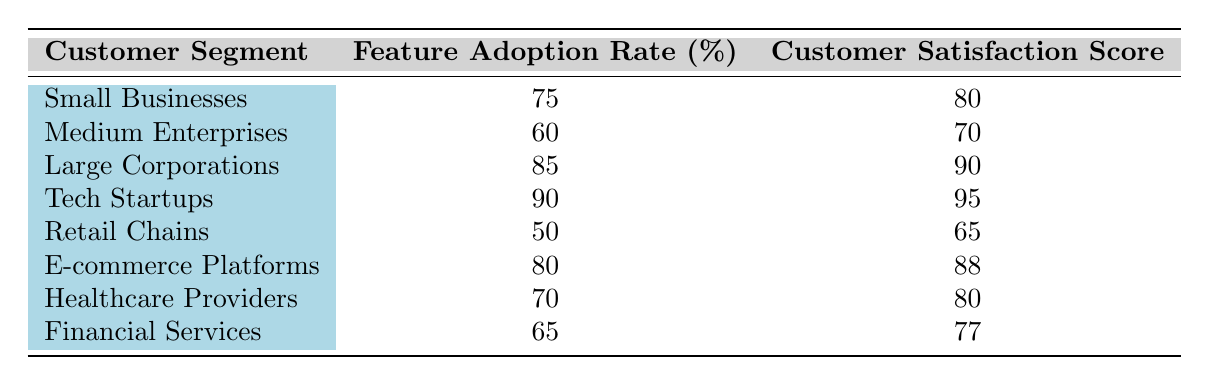What is the Feature Adoption Rate for Tech Startups? According to the table, Tech Startups have a Feature Adoption Rate of 90%.
Answer: 90% Which customer segment has the highest Customer Satisfaction Score? The table shows that Tech Startups have the highest Customer Satisfaction Score, which is 95.
Answer: Tech Startups What is the Customer Satisfaction Score for Medium Enterprises? The table indicates that Medium Enterprises have a Customer Satisfaction Score of 70.
Answer: 70 What is the difference in Customer Satisfaction Scores between Large Corporations and Retail Chains? Large Corporations have a score of 90, while Retail Chains score 65. The difference is 90 - 65 = 25.
Answer: 25 Are there any customer segments with a Feature Adoption Rate below 60%? Retail Chains have a Feature Adoption Rate of 50%, which is below 60%. Thus, the answer is yes.
Answer: Yes What is the average Customer Satisfaction Score across all segments listed? To calculate the average, sum all the Customer Satisfaction Scores: 80 + 70 + 90 + 95 + 65 + 88 + 80 + 77 = 645. There are 8 segments, so the average is 645 / 8 = 80.625, rounded to 81.
Answer: 81 Which customer segment has the lowest Feature Adoption Rate, and what is that rate? The table reveals that Retail Chains have the lowest Feature Adoption Rate at 50%.
Answer: Retail Chains, 50% If we consider a threshold of 75% Feature Adoption Rate, how many segments exceed this threshold? The segments that exceed 75% are Small Businesses (75), Large Corporations (85), Tech Startups (90), and E-commerce Platforms (80) making a total of 4 segments.
Answer: 4 What is the median Feature Adoption Rate from the list provided? First, we arrange the Feature Adoption Rates: 50, 60, 65, 70, 75, 80, 85, 90. Since there are 8 values, the median is the average of the 4th (70) and 5th (75) values: (70 + 75) / 2 = 72.5.
Answer: 72.5 